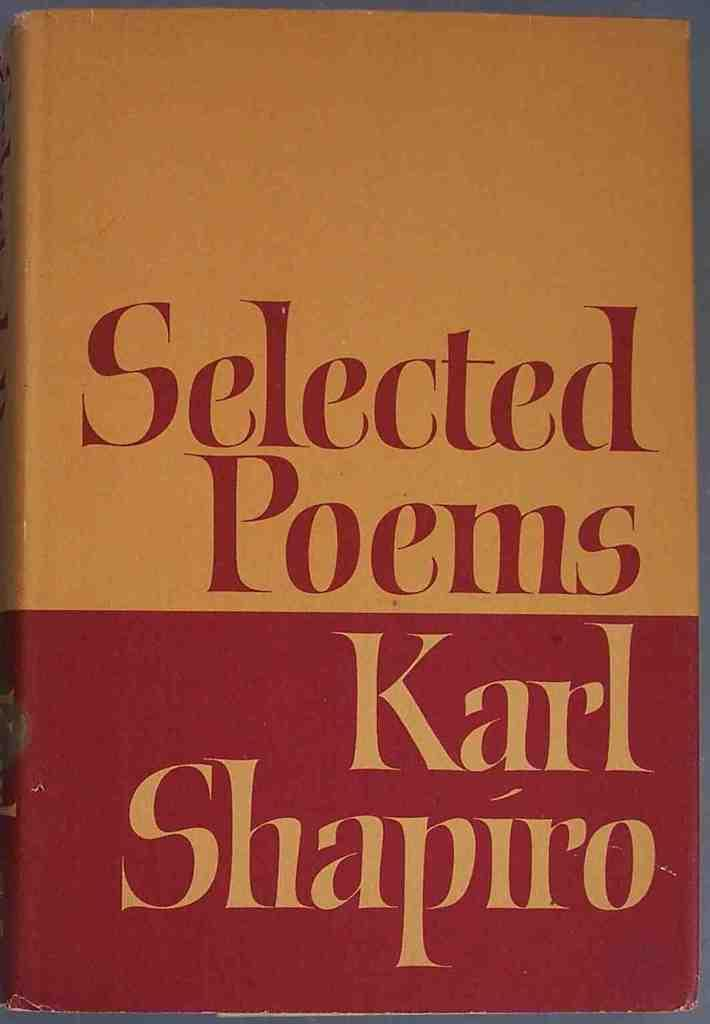<image>
Relay a brief, clear account of the picture shown. The book shown has a collection of different poems. 